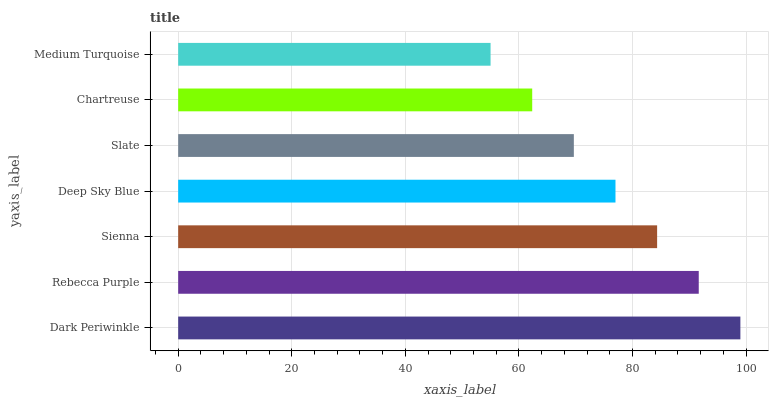Is Medium Turquoise the minimum?
Answer yes or no. Yes. Is Dark Periwinkle the maximum?
Answer yes or no. Yes. Is Rebecca Purple the minimum?
Answer yes or no. No. Is Rebecca Purple the maximum?
Answer yes or no. No. Is Dark Periwinkle greater than Rebecca Purple?
Answer yes or no. Yes. Is Rebecca Purple less than Dark Periwinkle?
Answer yes or no. Yes. Is Rebecca Purple greater than Dark Periwinkle?
Answer yes or no. No. Is Dark Periwinkle less than Rebecca Purple?
Answer yes or no. No. Is Deep Sky Blue the high median?
Answer yes or no. Yes. Is Deep Sky Blue the low median?
Answer yes or no. Yes. Is Medium Turquoise the high median?
Answer yes or no. No. Is Dark Periwinkle the low median?
Answer yes or no. No. 